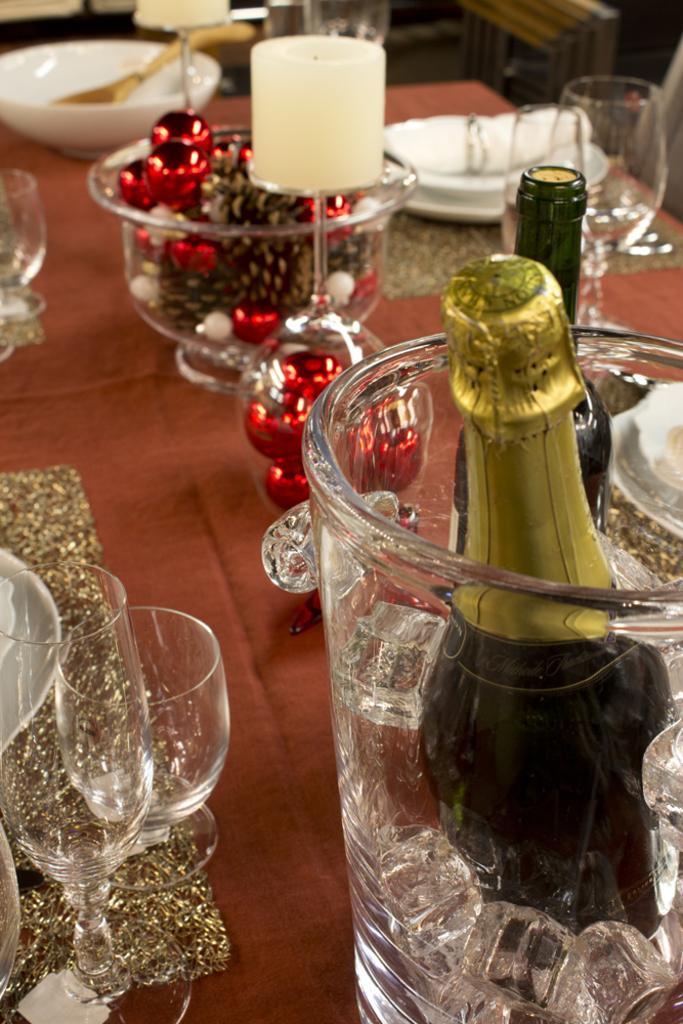What type of tableware can be seen in the image? There are glasses in the image. What food items are present in the image? There are food items in a bowl in the image. What is the champagne bottle placed in? The champagne bottle is placed in an ice cubes jar in the image. Where are these objects located? The objects are on a table in the image. What type of locket is hanging from the fowl in the image? There is no locket or fowl present in the image. 